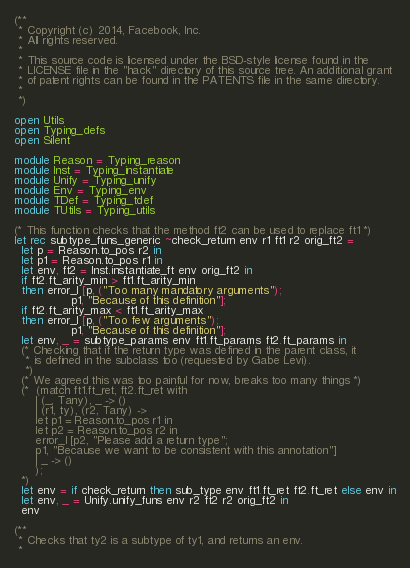Convert code to text. <code><loc_0><loc_0><loc_500><loc_500><_OCaml_>(**
 * Copyright (c) 2014, Facebook, Inc.
 * All rights reserved.
 *
 * This source code is licensed under the BSD-style license found in the
 * LICENSE file in the "hack" directory of this source tree. An additional grant
 * of patent rights can be found in the PATENTS file in the same directory.
 *
 *)

open Utils
open Typing_defs
open Silent

module Reason = Typing_reason
module Inst = Typing_instantiate
module Unify = Typing_unify
module Env = Typing_env
module TDef = Typing_tdef
module TUtils = Typing_utils

(* This function checks that the method ft2 can be used to replace ft1 *)
let rec subtype_funs_generic ~check_return env r1 ft1 r2 orig_ft2 =
  let p = Reason.to_pos r2 in
  let p1 = Reason.to_pos r1 in
  let env, ft2 = Inst.instantiate_ft env orig_ft2 in
  if ft2.ft_arity_min > ft1.ft_arity_min
  then error_l [p, ("Too many mandatory arguments");
                p1, "Because of this definition"];
  if ft2.ft_arity_max < ft1.ft_arity_max
  then error_l [p, ("Too few arguments");
                p1, "Because of this definition"];
  let env, _ = subtype_params env ft1.ft_params ft2.ft_params in
  (* Checking that if the return type was defined in the parent class, it
   * is defined in the subclass too (requested by Gabe Levi).
   *)
  (* We agreed this was too painful for now, breaks too many things *)
  (*  (match ft1.ft_ret, ft2.ft_ret with
      | (_, Tany), _ -> ()
      | (r1, ty), (r2, Tany) ->
      let p1 = Reason.to_pos r1 in
      let p2 = Reason.to_pos r2 in
      error_l [p2, "Please add a return type";
      p1, "Because we want to be consistent with this annotation"]
      | _ -> ()
      );
  *)
  let env = if check_return then sub_type env ft1.ft_ret ft2.ft_ret else env in
  let env, _ = Unify.unify_funs env r2 ft2 r2 orig_ft2 in
  env

(**
 * Checks that ty2 is a subtype of ty1, and returns an env.
 *</code> 